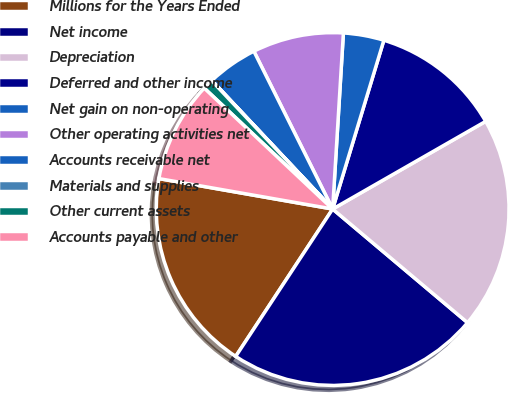<chart> <loc_0><loc_0><loc_500><loc_500><pie_chart><fcel>Millions for the Years Ended<fcel>Net income<fcel>Depreciation<fcel>Deferred and other income<fcel>Net gain on non-operating<fcel>Other operating activities net<fcel>Accounts receivable net<fcel>Materials and supplies<fcel>Other current assets<fcel>Accounts payable and other<nl><fcel>18.5%<fcel>23.12%<fcel>19.42%<fcel>12.03%<fcel>3.72%<fcel>8.34%<fcel>4.64%<fcel>0.02%<fcel>0.95%<fcel>9.26%<nl></chart> 